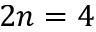Convert formula to latex. <formula><loc_0><loc_0><loc_500><loc_500>2 n = 4</formula> 